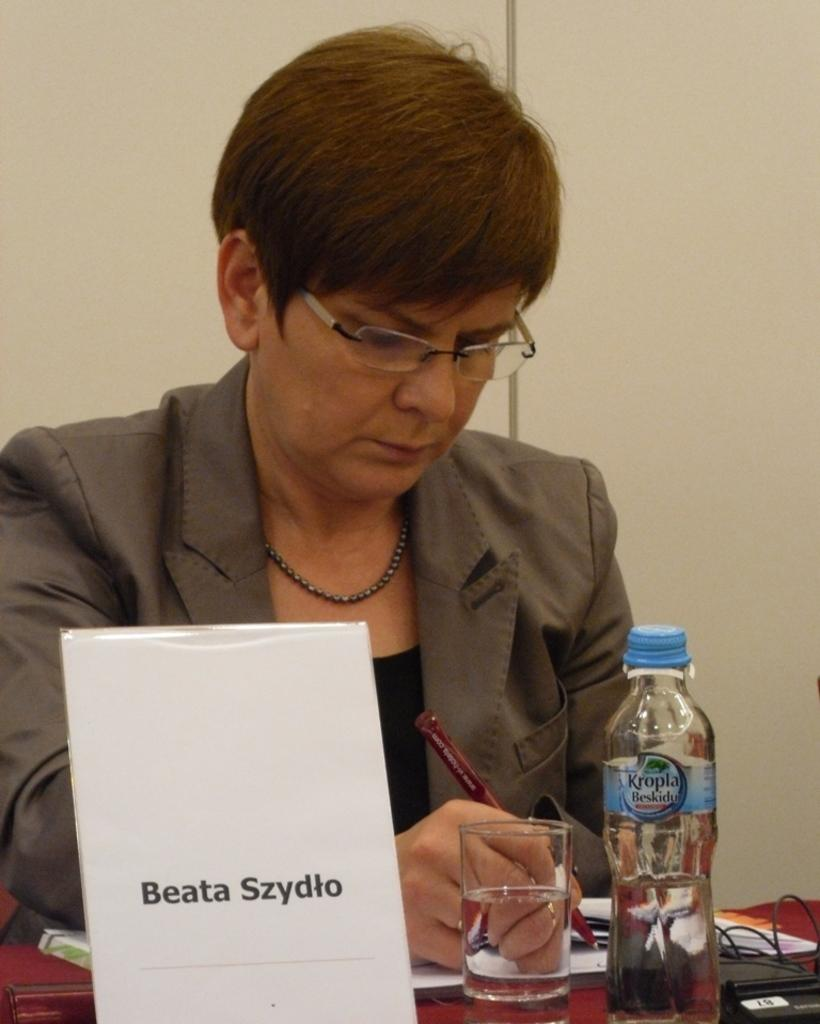What is the main subject of the image? There is a woman in the image. What is the woman doing in the image? The woman is sitting. What is the woman holding in her hand? The woman is holding a pen in her hand. What objects can be seen on the table in the image? There is a glass, a bottle, a name board, and a book on the table. What type of feather can be seen on the woman's hat in the image? There is no feather present on the woman's hat in the image. Can you tell me how many airports are visible in the image? There are no airports present in the image. 